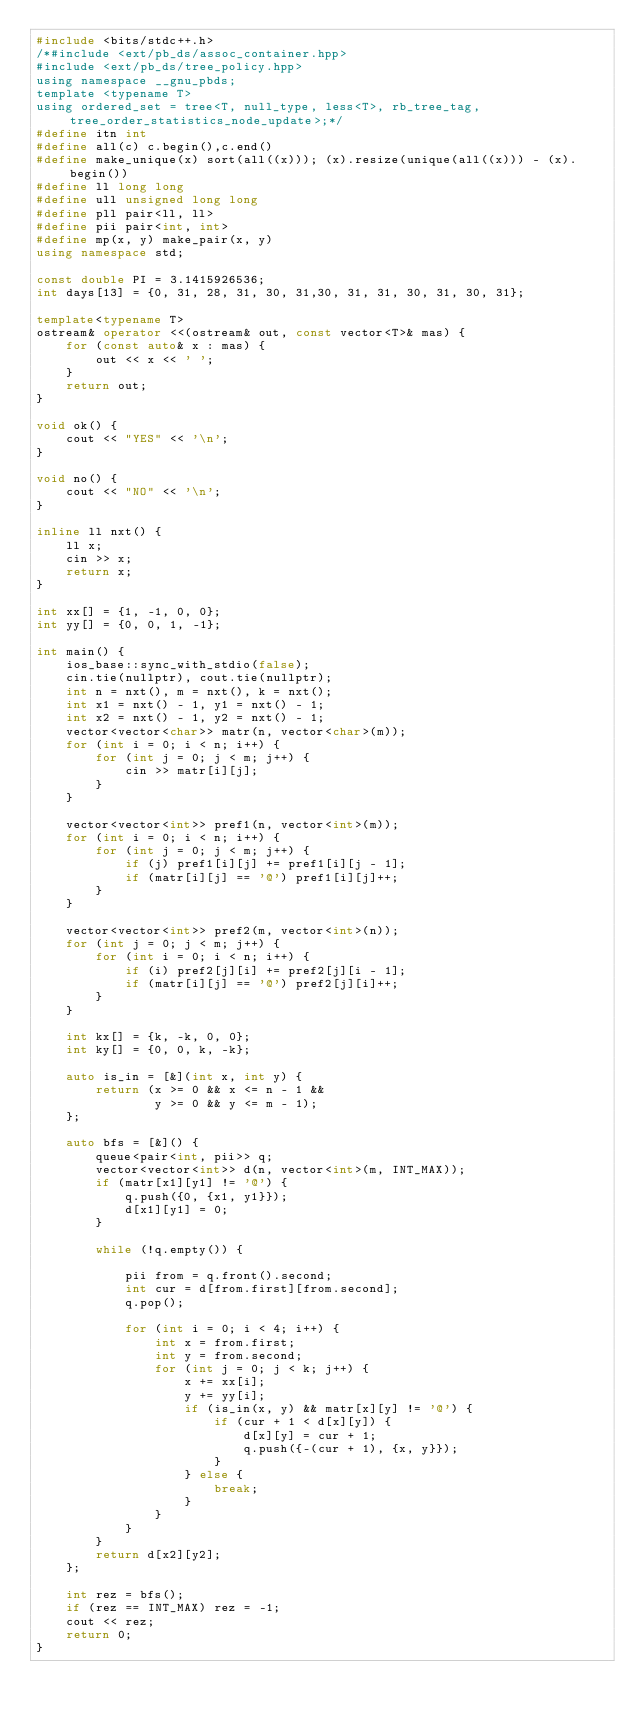Convert code to text. <code><loc_0><loc_0><loc_500><loc_500><_C++_>#include <bits/stdc++.h>
/*#include <ext/pb_ds/assoc_container.hpp>
#include <ext/pb_ds/tree_policy.hpp>
using namespace __gnu_pbds;
template <typename T>
using ordered_set = tree<T, null_type, less<T>, rb_tree_tag, tree_order_statistics_node_update>;*/
#define itn int
#define all(c) c.begin(),c.end()
#define make_unique(x) sort(all((x))); (x).resize(unique(all((x))) - (x).begin())
#define ll long long
#define ull unsigned long long
#define pll pair<ll, ll>
#define pii pair<int, int>
#define mp(x, y) make_pair(x, y)
using namespace std; 

const double PI = 3.1415926536;
int days[13] = {0, 31, 28, 31, 30, 31,30, 31, 31, 30, 31, 30, 31};

template<typename T>
ostream& operator <<(ostream& out, const vector<T>& mas) {
    for (const auto& x : mas) {
        out << x << ' ';
    }
    return out;
}

void ok() {
    cout << "YES" << '\n';
}

void no() {
    cout << "NO" << '\n';
}

inline ll nxt() {
    ll x;
    cin >> x;
    return x;
} 
 
int xx[] = {1, -1, 0, 0};
int yy[] = {0, 0, 1, -1};

int main() {
    ios_base::sync_with_stdio(false);
    cin.tie(nullptr), cout.tie(nullptr);
    int n = nxt(), m = nxt(), k = nxt();
    int x1 = nxt() - 1, y1 = nxt() - 1;
    int x2 = nxt() - 1, y2 = nxt() - 1;
    vector<vector<char>> matr(n, vector<char>(m));
    for (int i = 0; i < n; i++) {
        for (int j = 0; j < m; j++) {
            cin >> matr[i][j];
        }
    }

    vector<vector<int>> pref1(n, vector<int>(m));
    for (int i = 0; i < n; i++) {
        for (int j = 0; j < m; j++) {
            if (j) pref1[i][j] += pref1[i][j - 1];
            if (matr[i][j] == '@') pref1[i][j]++;
        }
    }

    vector<vector<int>> pref2(m, vector<int>(n));
    for (int j = 0; j < m; j++) {
        for (int i = 0; i < n; i++) {
            if (i) pref2[j][i] += pref2[j][i - 1];
            if (matr[i][j] == '@') pref2[j][i]++;
        }
    }

    int kx[] = {k, -k, 0, 0};
    int ky[] = {0, 0, k, -k};

    auto is_in = [&](int x, int y) {
        return (x >= 0 && x <= n - 1 && 
                y >= 0 && y <= m - 1);
    };

    auto bfs = [&]() {
        queue<pair<int, pii>> q; 
        vector<vector<int>> d(n, vector<int>(m, INT_MAX));
        if (matr[x1][y1] != '@') {
            q.push({0, {x1, y1}});
            d[x1][y1] = 0;
        } 
        
        while (!q.empty()) {
            
            pii from = q.front().second;
            int cur = d[from.first][from.second];
            q.pop();
            
            for (int i = 0; i < 4; i++) {
                int x = from.first;
                int y = from.second;
                for (int j = 0; j < k; j++) {
                    x += xx[i];
                    y += yy[i];
                    if (is_in(x, y) && matr[x][y] != '@') {
                        if (cur + 1 < d[x][y]) {
                            d[x][y] = cur + 1;
                            q.push({-(cur + 1), {x, y}});
                        } 
                    } else {
                        break;
                    }
                }
            } 
        } 
        return d[x2][y2];
    }; 

    int rez = bfs();
    if (rez == INT_MAX) rez = -1;
    cout << rez;
    return 0;
}
</code> 